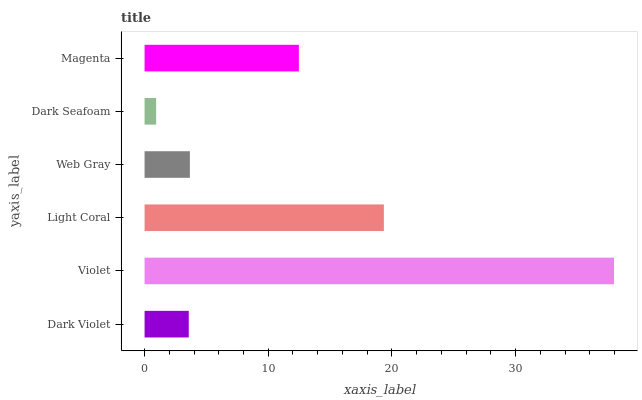Is Dark Seafoam the minimum?
Answer yes or no. Yes. Is Violet the maximum?
Answer yes or no. Yes. Is Light Coral the minimum?
Answer yes or no. No. Is Light Coral the maximum?
Answer yes or no. No. Is Violet greater than Light Coral?
Answer yes or no. Yes. Is Light Coral less than Violet?
Answer yes or no. Yes. Is Light Coral greater than Violet?
Answer yes or no. No. Is Violet less than Light Coral?
Answer yes or no. No. Is Magenta the high median?
Answer yes or no. Yes. Is Web Gray the low median?
Answer yes or no. Yes. Is Dark Violet the high median?
Answer yes or no. No. Is Dark Seafoam the low median?
Answer yes or no. No. 